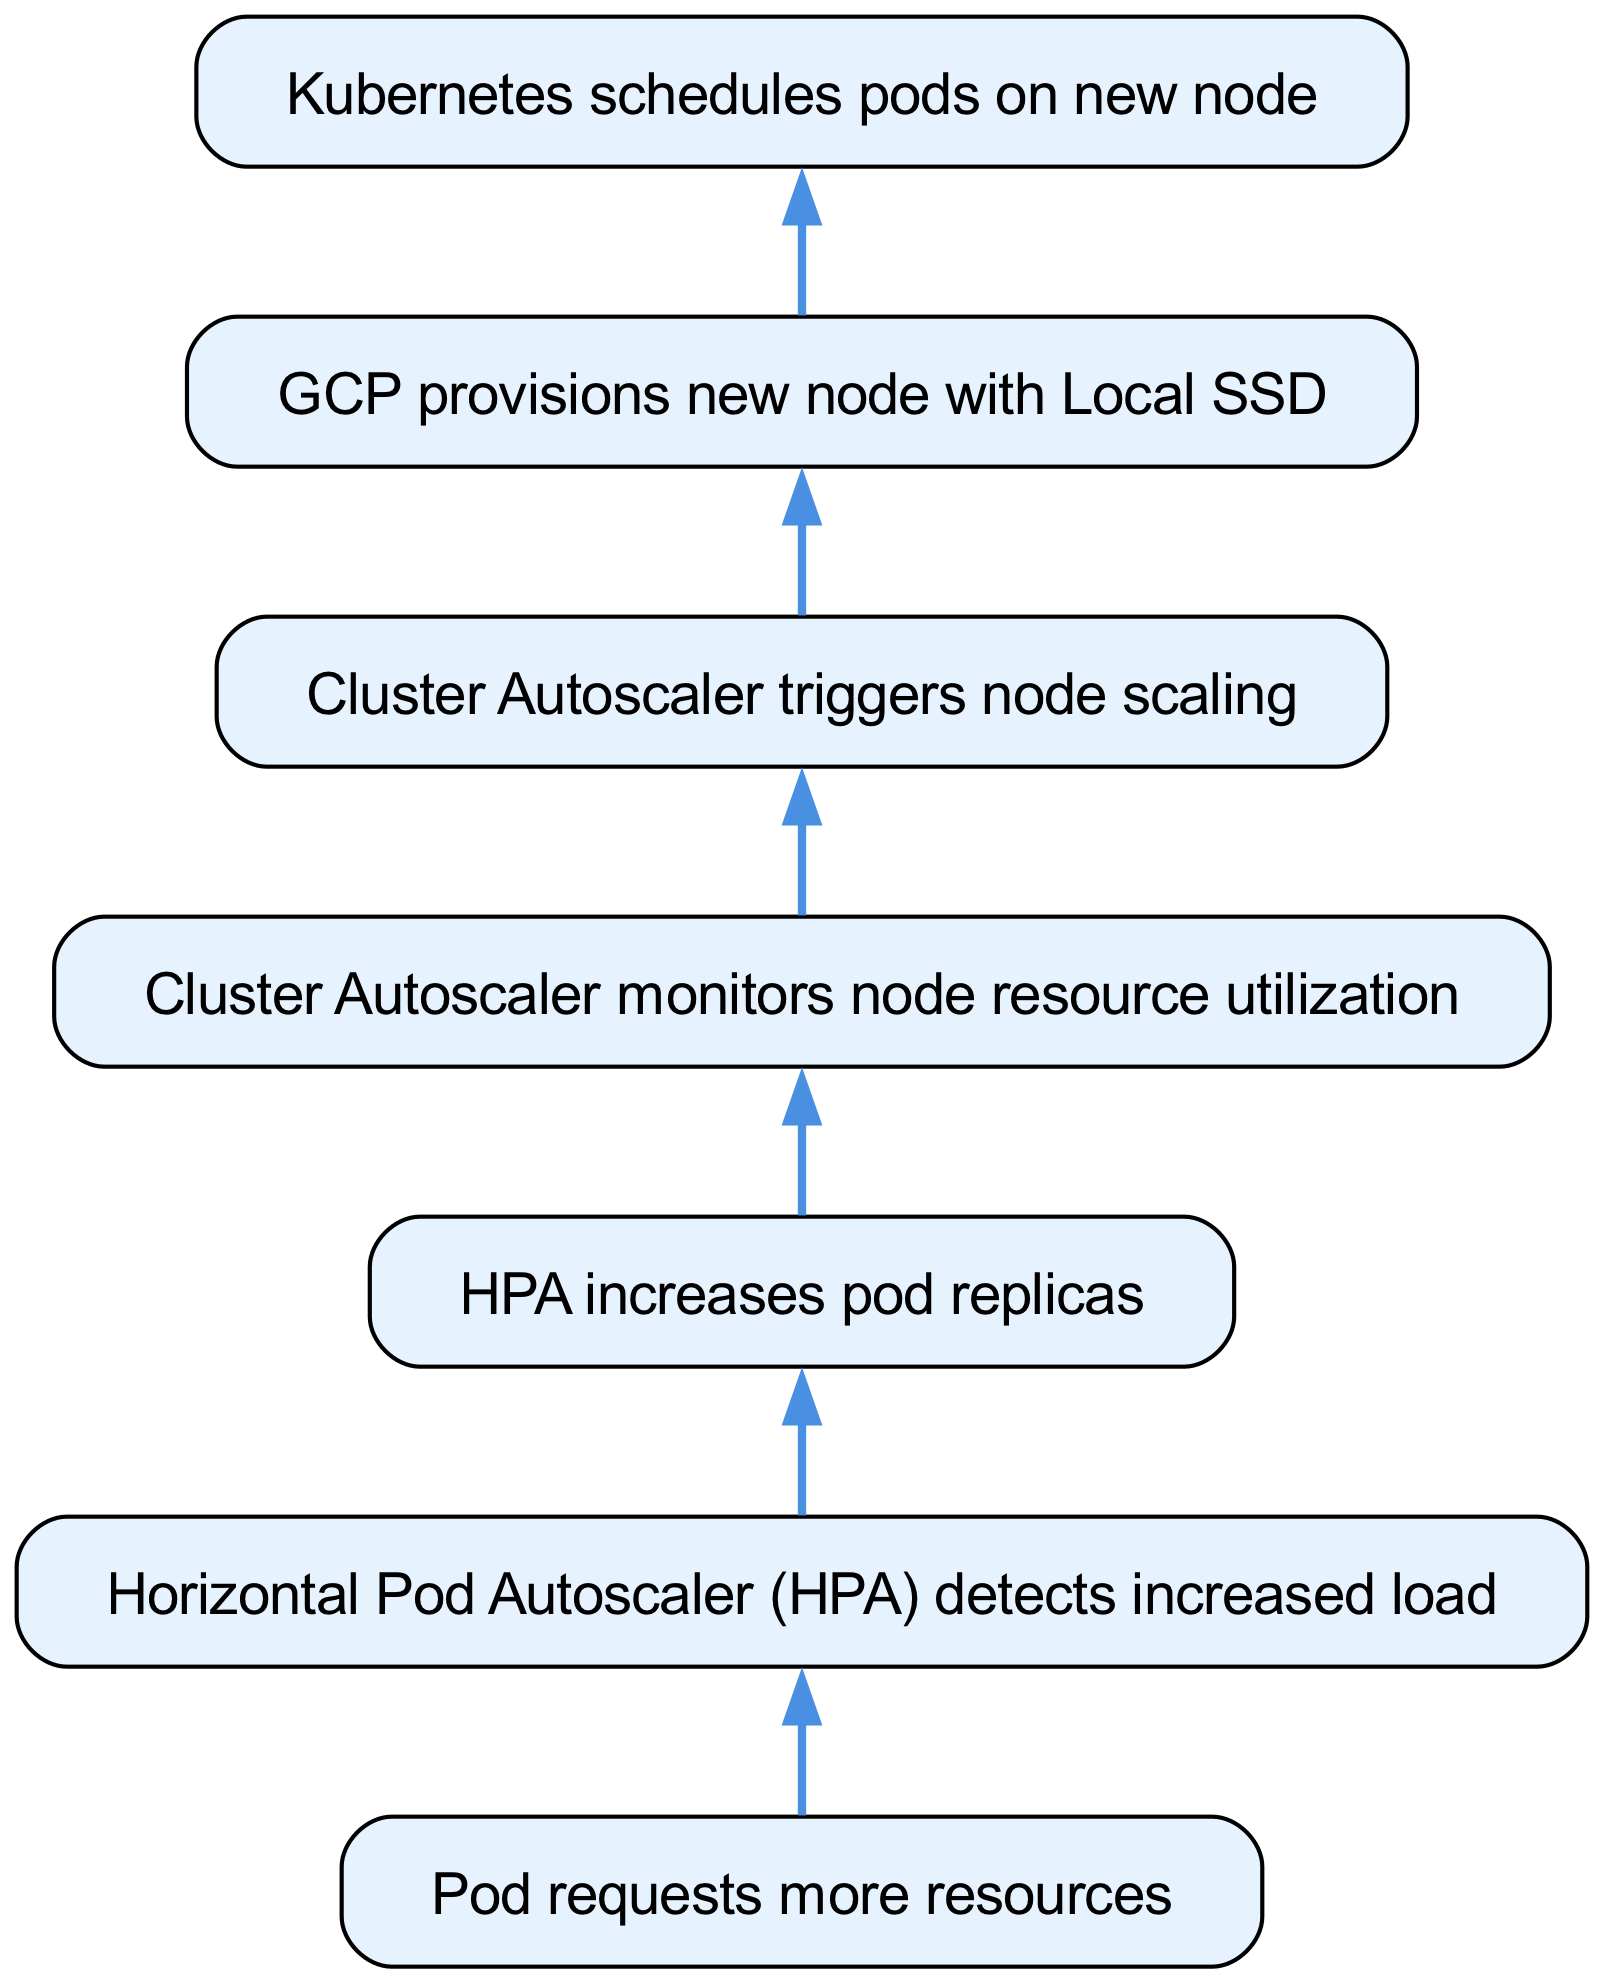What triggers the Horizontal Pod Autoscaler? The initial node shows that pod requests more resources, which triggers the detection of increased load by the Horizontal Pod Autoscaler.
Answer: Pod requests more resources How many edges are in the diagram? By counting all the connections between nodes, there are six edges represented in the diagram.
Answer: 6 What does the Cluster Autoscaler do after monitoring node resource utilization? After monitoring, the Cluster Autoscaler triggers node scaling as indicated in the flow from the monitoring node to the scaling node.
Answer: Triggers node scaling Which node follows the provision of a new node with Local SSD? After a new node is provisioned with Local SSD, the next step is that Kubernetes schedules pods on the new node, creating a direct connection in the flow from the provisioning node to the scheduling node.
Answer: Kubernetes schedules pods on new node What is the last action taken in the scaling process represented in the diagram? The final node in the flowchart indicates that the last action is Kubernetes scheduling pods on the new node, concluding the scaling process.
Answer: Kubernetes schedules pods on new node What does the diagram illustrate about the scaling process? The overall flow of the diagram shows a sequential process of scaling from pod resource requests to node provisioning and pod scheduling, highlighting interactions between different components.
Answer: Kubernetes cluster scaling process What is the relationship between the nodes that detect increased load and increase pod replicas? The Horizontal Pod Autoscaler detects increased load, which leads directly to the action of increasing pod replicas, showing a direct cause-effect relationship between these two nodes.
Answer: Cause-effect relationship 